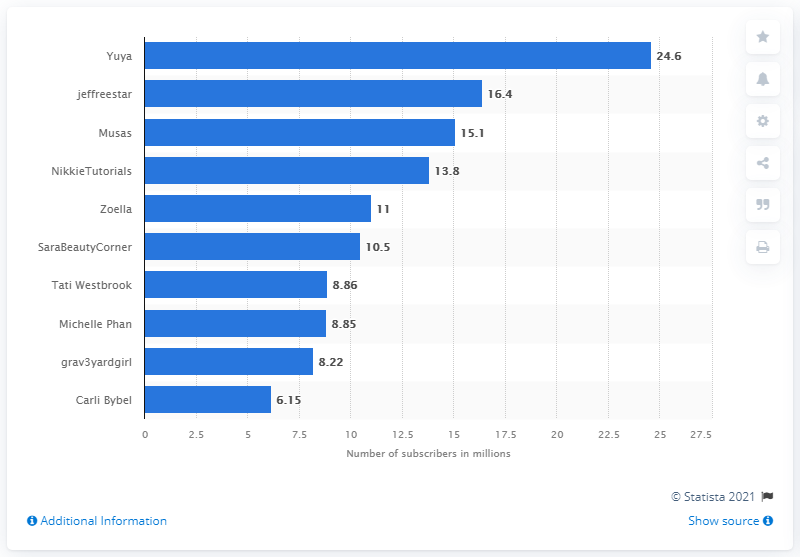Mention a couple of crucial points in this snapshot. In May 2021, Carli Bybel had the least number of subscribers among all users on YouTube. The median number of subscribers is 10.75. The most subscribed beauty content creator on YouTube in May 2021 was Yuya. 